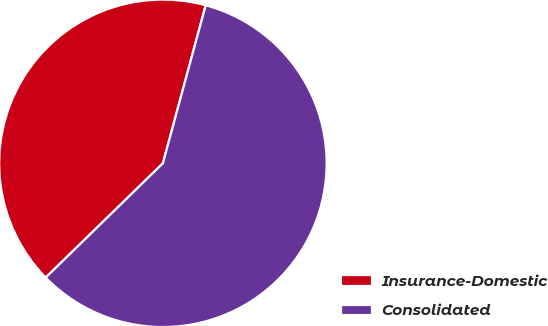<chart> <loc_0><loc_0><loc_500><loc_500><pie_chart><fcel>Insurance-Domestic<fcel>Consolidated<nl><fcel>41.51%<fcel>58.49%<nl></chart> 